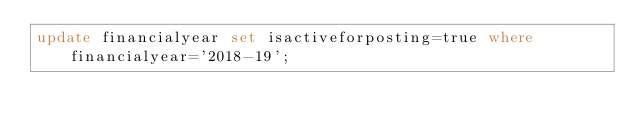Convert code to text. <code><loc_0><loc_0><loc_500><loc_500><_SQL_>update financialyear set isactiveforposting=true where financialyear='2018-19';
</code> 